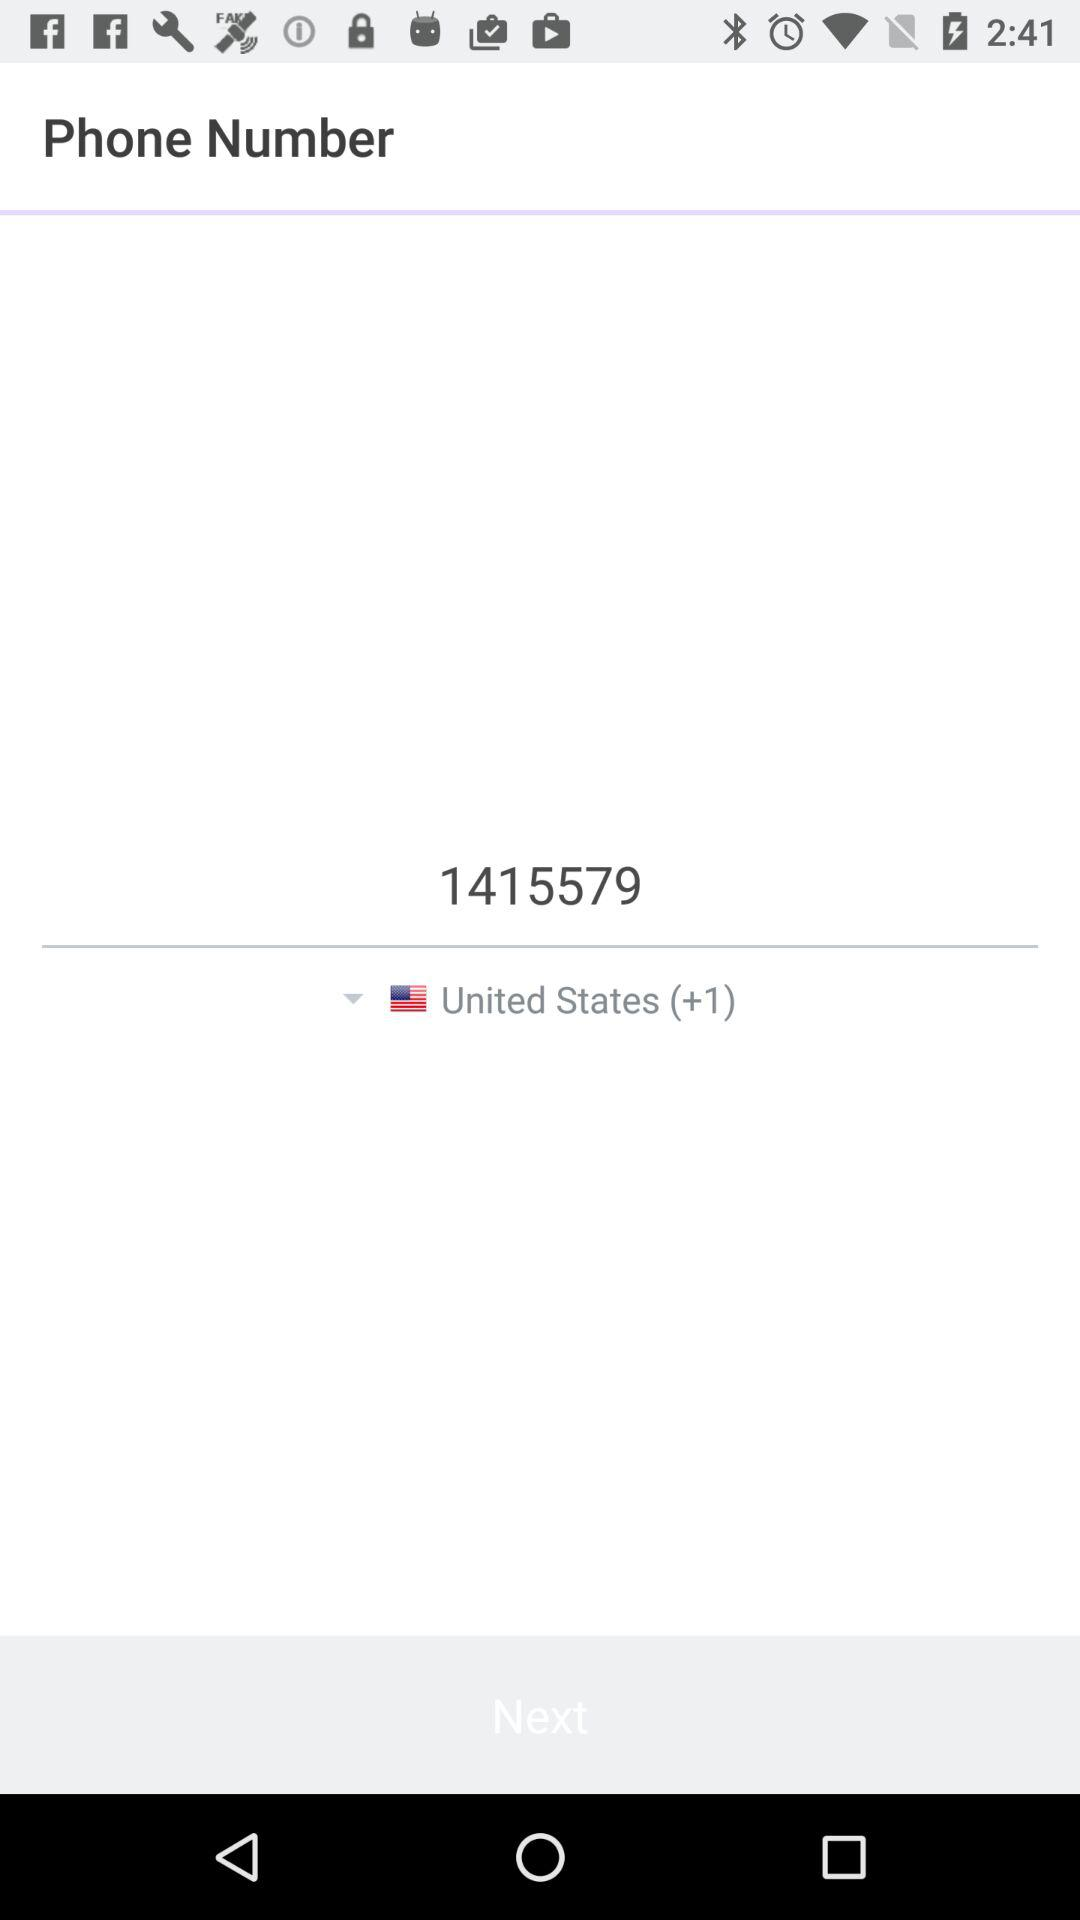Which country is selected? The selected country is the United States. 